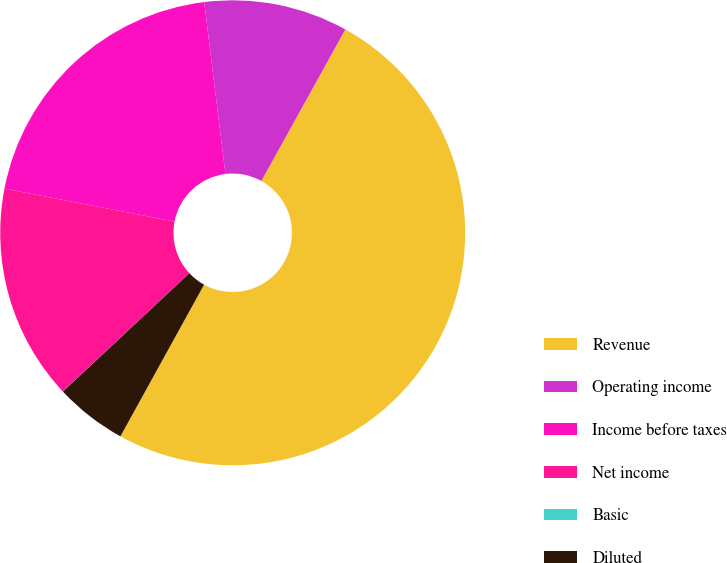Convert chart to OTSL. <chart><loc_0><loc_0><loc_500><loc_500><pie_chart><fcel>Revenue<fcel>Operating income<fcel>Income before taxes<fcel>Net income<fcel>Basic<fcel>Diluted<nl><fcel>49.97%<fcel>10.01%<fcel>20.0%<fcel>15.0%<fcel>0.01%<fcel>5.01%<nl></chart> 